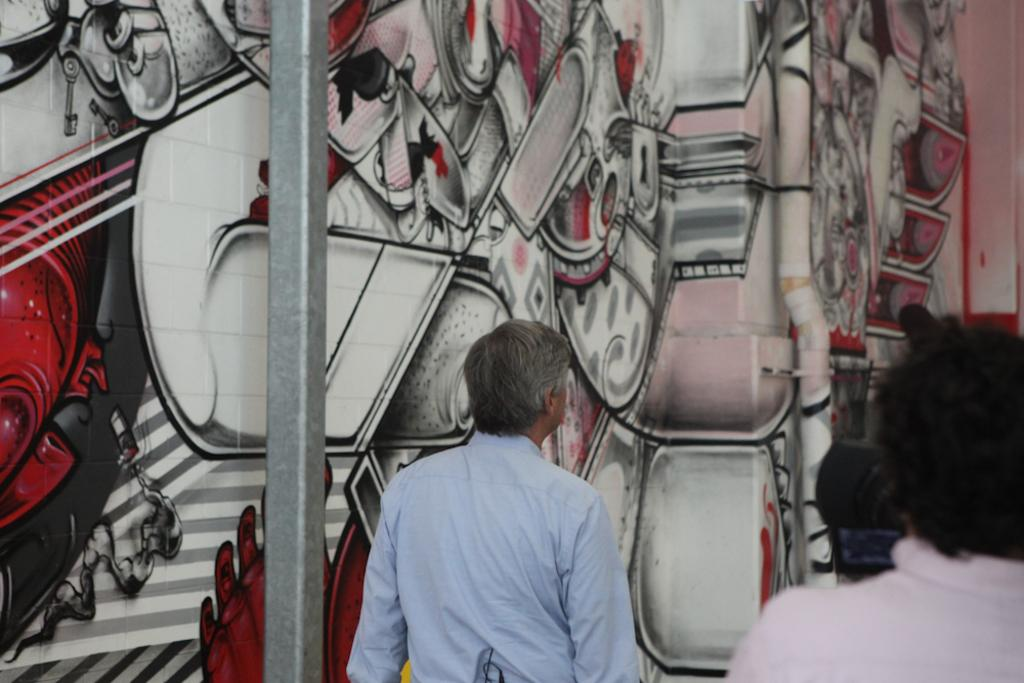What is on the wall in the image? There is a painting on the wall in the image. What are the people in the image doing? The people are standing and watching the painting. What can be seen on the side in the image? There is a metal pole on the side in the image. What type of mint is being used as a scarf in the image? There is no mint or scarf present in the image. What holiday is being celebrated in the image? There is no indication of a holiday being celebrated in the image. 